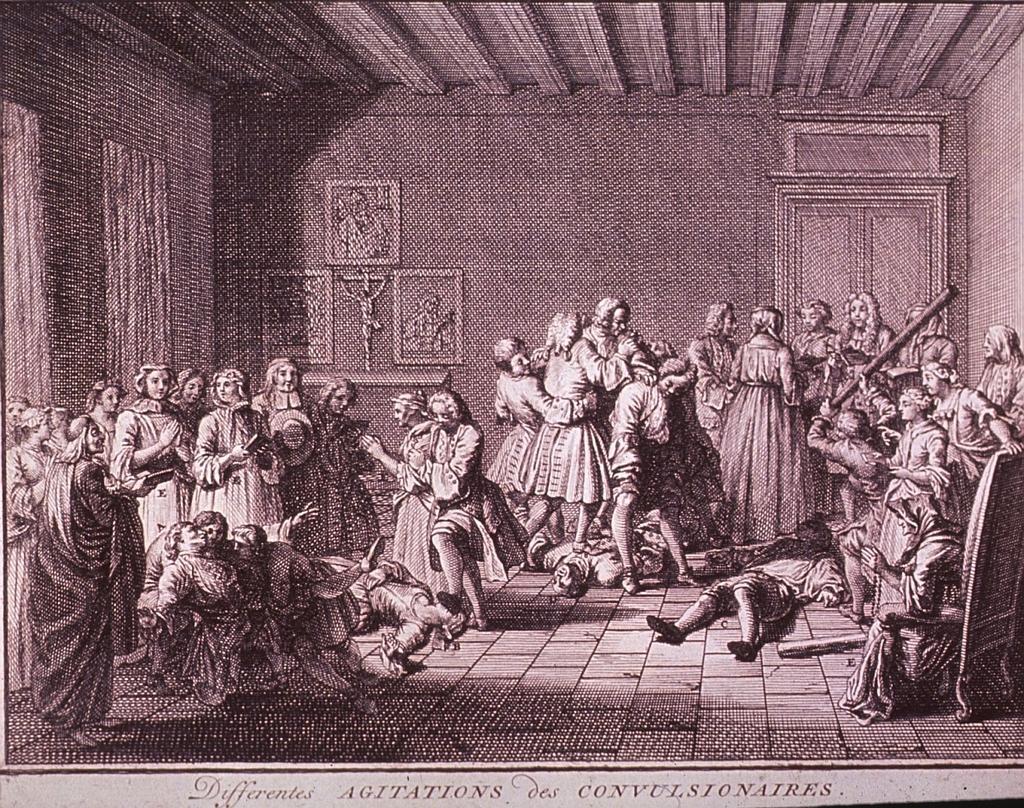In one or two sentences, can you explain what this image depicts? In this image, we can see a picture, on that picture there are some people standing and there are some photos on the wall, at the right side there is a window and at the top there is a shed. 